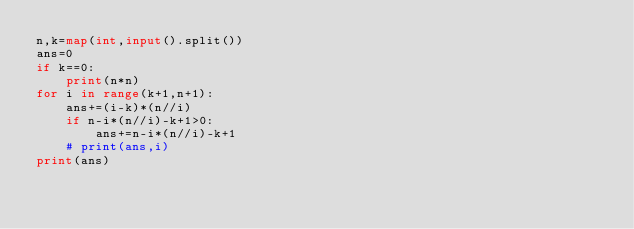Convert code to text. <code><loc_0><loc_0><loc_500><loc_500><_Python_>n,k=map(int,input().split())
ans=0
if k==0:
    print(n*n)
for i in range(k+1,n+1):
    ans+=(i-k)*(n//i)
    if n-i*(n//i)-k+1>0:
        ans+=n-i*(n//i)-k+1
    # print(ans,i)
print(ans)</code> 